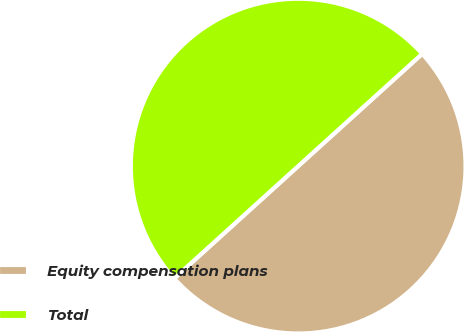Convert chart to OTSL. <chart><loc_0><loc_0><loc_500><loc_500><pie_chart><fcel>Equity compensation plans<fcel>Total<nl><fcel>50.0%<fcel>50.0%<nl></chart> 